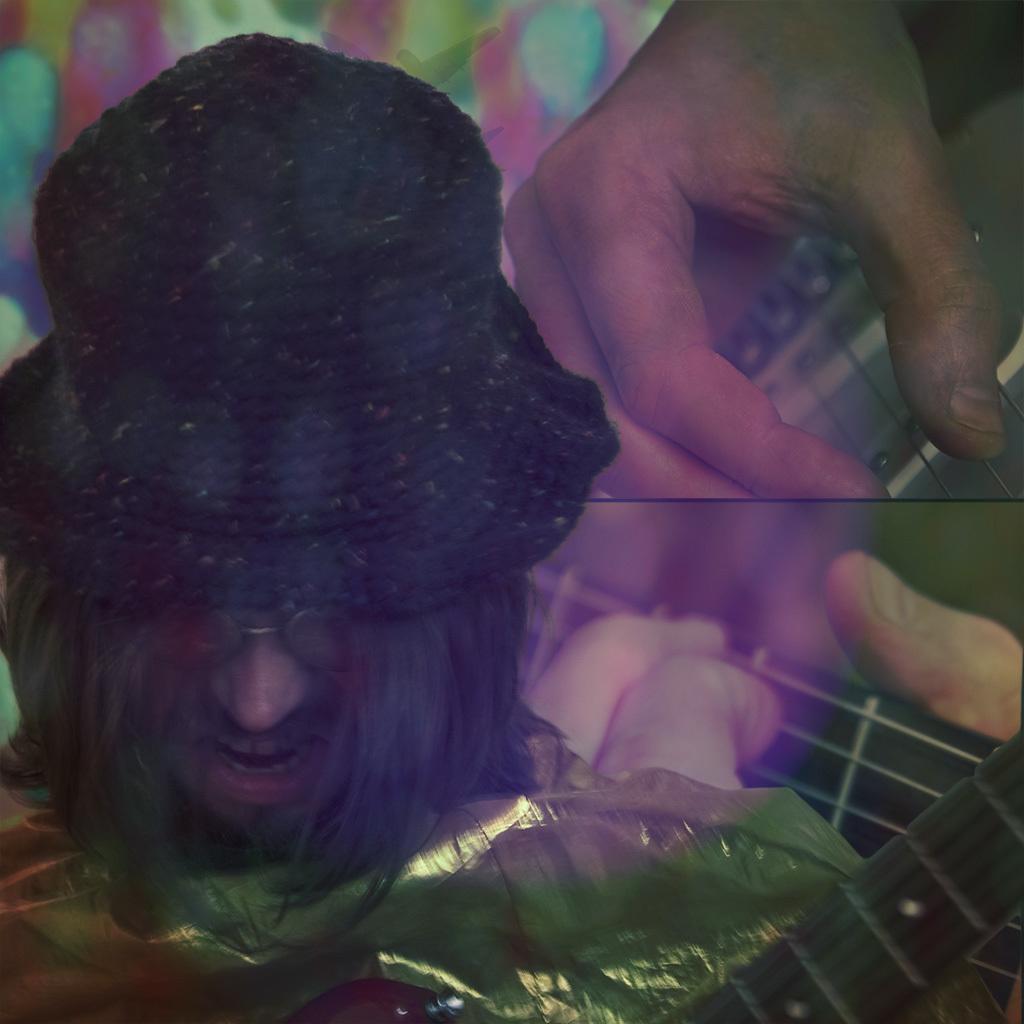How would you summarize this image in a sentence or two? This is an edited image and in this picture we can see a cover, guitars, persons hands and a man wore a spectacle, cap. 